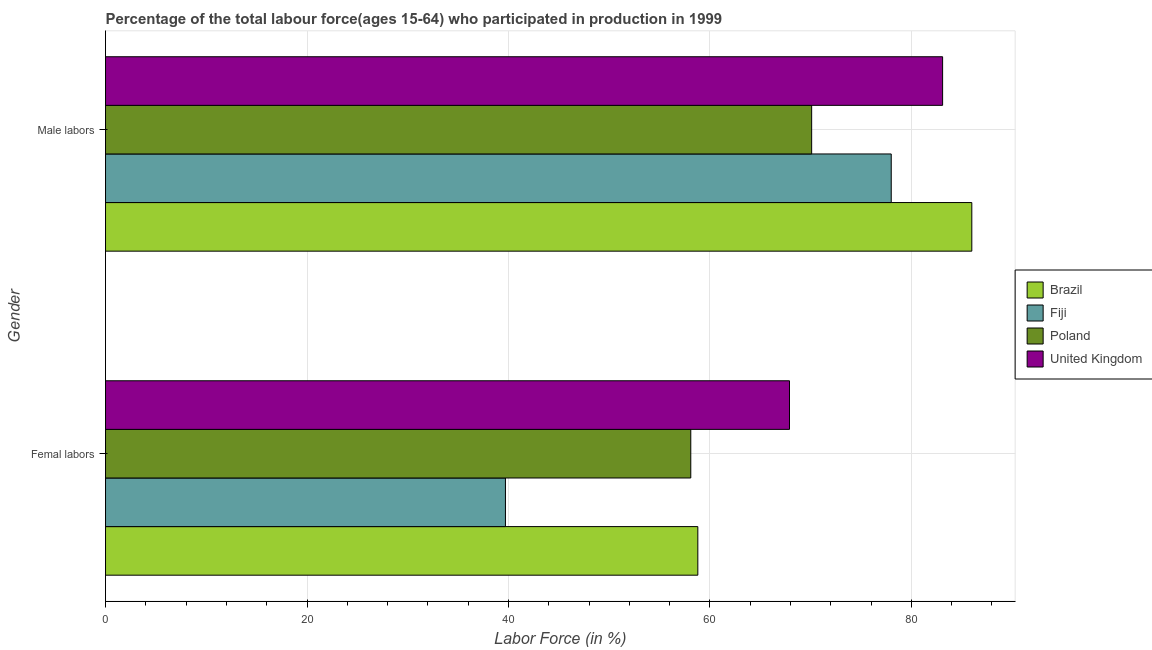How many different coloured bars are there?
Offer a very short reply. 4. How many groups of bars are there?
Provide a short and direct response. 2. Are the number of bars per tick equal to the number of legend labels?
Offer a terse response. Yes. What is the label of the 2nd group of bars from the top?
Your answer should be very brief. Femal labors. What is the percentage of female labor force in Brazil?
Provide a short and direct response. 58.8. Across all countries, what is the minimum percentage of male labour force?
Keep it short and to the point. 70.1. In which country was the percentage of male labour force maximum?
Your answer should be very brief. Brazil. In which country was the percentage of female labor force minimum?
Your answer should be compact. Fiji. What is the total percentage of male labour force in the graph?
Offer a terse response. 317.2. What is the difference between the percentage of male labour force in United Kingdom and that in Fiji?
Your response must be concise. 5.1. What is the difference between the percentage of male labour force in Poland and the percentage of female labor force in Fiji?
Give a very brief answer. 30.4. What is the average percentage of female labor force per country?
Ensure brevity in your answer.  56.12. What is the difference between the percentage of female labor force and percentage of male labour force in Brazil?
Your response must be concise. -27.2. What is the ratio of the percentage of female labor force in Poland to that in Brazil?
Offer a terse response. 0.99. What does the 3rd bar from the top in Femal labors represents?
Make the answer very short. Fiji. Are all the bars in the graph horizontal?
Provide a short and direct response. Yes. How many countries are there in the graph?
Your response must be concise. 4. What is the difference between two consecutive major ticks on the X-axis?
Give a very brief answer. 20. Are the values on the major ticks of X-axis written in scientific E-notation?
Your response must be concise. No. Does the graph contain any zero values?
Ensure brevity in your answer.  No. Does the graph contain grids?
Your response must be concise. Yes. How are the legend labels stacked?
Give a very brief answer. Vertical. What is the title of the graph?
Give a very brief answer. Percentage of the total labour force(ages 15-64) who participated in production in 1999. Does "Grenada" appear as one of the legend labels in the graph?
Your response must be concise. No. What is the label or title of the X-axis?
Offer a terse response. Labor Force (in %). What is the label or title of the Y-axis?
Give a very brief answer. Gender. What is the Labor Force (in %) in Brazil in Femal labors?
Make the answer very short. 58.8. What is the Labor Force (in %) in Fiji in Femal labors?
Provide a succinct answer. 39.7. What is the Labor Force (in %) in Poland in Femal labors?
Offer a terse response. 58.1. What is the Labor Force (in %) in United Kingdom in Femal labors?
Your response must be concise. 67.9. What is the Labor Force (in %) in Poland in Male labors?
Ensure brevity in your answer.  70.1. What is the Labor Force (in %) of United Kingdom in Male labors?
Your response must be concise. 83.1. Across all Gender, what is the maximum Labor Force (in %) in Poland?
Offer a terse response. 70.1. Across all Gender, what is the maximum Labor Force (in %) in United Kingdom?
Keep it short and to the point. 83.1. Across all Gender, what is the minimum Labor Force (in %) in Brazil?
Provide a short and direct response. 58.8. Across all Gender, what is the minimum Labor Force (in %) in Fiji?
Your response must be concise. 39.7. Across all Gender, what is the minimum Labor Force (in %) in Poland?
Keep it short and to the point. 58.1. Across all Gender, what is the minimum Labor Force (in %) in United Kingdom?
Keep it short and to the point. 67.9. What is the total Labor Force (in %) in Brazil in the graph?
Ensure brevity in your answer.  144.8. What is the total Labor Force (in %) of Fiji in the graph?
Provide a short and direct response. 117.7. What is the total Labor Force (in %) of Poland in the graph?
Your answer should be very brief. 128.2. What is the total Labor Force (in %) in United Kingdom in the graph?
Offer a terse response. 151. What is the difference between the Labor Force (in %) of Brazil in Femal labors and that in Male labors?
Give a very brief answer. -27.2. What is the difference between the Labor Force (in %) in Fiji in Femal labors and that in Male labors?
Your answer should be very brief. -38.3. What is the difference between the Labor Force (in %) of United Kingdom in Femal labors and that in Male labors?
Ensure brevity in your answer.  -15.2. What is the difference between the Labor Force (in %) of Brazil in Femal labors and the Labor Force (in %) of Fiji in Male labors?
Offer a very short reply. -19.2. What is the difference between the Labor Force (in %) in Brazil in Femal labors and the Labor Force (in %) in United Kingdom in Male labors?
Your response must be concise. -24.3. What is the difference between the Labor Force (in %) in Fiji in Femal labors and the Labor Force (in %) in Poland in Male labors?
Keep it short and to the point. -30.4. What is the difference between the Labor Force (in %) of Fiji in Femal labors and the Labor Force (in %) of United Kingdom in Male labors?
Make the answer very short. -43.4. What is the average Labor Force (in %) in Brazil per Gender?
Give a very brief answer. 72.4. What is the average Labor Force (in %) in Fiji per Gender?
Your answer should be compact. 58.85. What is the average Labor Force (in %) of Poland per Gender?
Offer a very short reply. 64.1. What is the average Labor Force (in %) in United Kingdom per Gender?
Offer a terse response. 75.5. What is the difference between the Labor Force (in %) in Brazil and Labor Force (in %) in Fiji in Femal labors?
Ensure brevity in your answer.  19.1. What is the difference between the Labor Force (in %) in Brazil and Labor Force (in %) in Poland in Femal labors?
Ensure brevity in your answer.  0.7. What is the difference between the Labor Force (in %) in Brazil and Labor Force (in %) in United Kingdom in Femal labors?
Give a very brief answer. -9.1. What is the difference between the Labor Force (in %) in Fiji and Labor Force (in %) in Poland in Femal labors?
Keep it short and to the point. -18.4. What is the difference between the Labor Force (in %) of Fiji and Labor Force (in %) of United Kingdom in Femal labors?
Provide a succinct answer. -28.2. What is the difference between the Labor Force (in %) of Poland and Labor Force (in %) of United Kingdom in Femal labors?
Your answer should be very brief. -9.8. What is the difference between the Labor Force (in %) in Poland and Labor Force (in %) in United Kingdom in Male labors?
Offer a terse response. -13. What is the ratio of the Labor Force (in %) in Brazil in Femal labors to that in Male labors?
Your answer should be compact. 0.68. What is the ratio of the Labor Force (in %) in Fiji in Femal labors to that in Male labors?
Your response must be concise. 0.51. What is the ratio of the Labor Force (in %) of Poland in Femal labors to that in Male labors?
Keep it short and to the point. 0.83. What is the ratio of the Labor Force (in %) of United Kingdom in Femal labors to that in Male labors?
Offer a very short reply. 0.82. What is the difference between the highest and the second highest Labor Force (in %) of Brazil?
Your answer should be compact. 27.2. What is the difference between the highest and the second highest Labor Force (in %) of Fiji?
Provide a succinct answer. 38.3. What is the difference between the highest and the lowest Labor Force (in %) in Brazil?
Keep it short and to the point. 27.2. What is the difference between the highest and the lowest Labor Force (in %) of Fiji?
Your answer should be compact. 38.3. What is the difference between the highest and the lowest Labor Force (in %) in United Kingdom?
Keep it short and to the point. 15.2. 